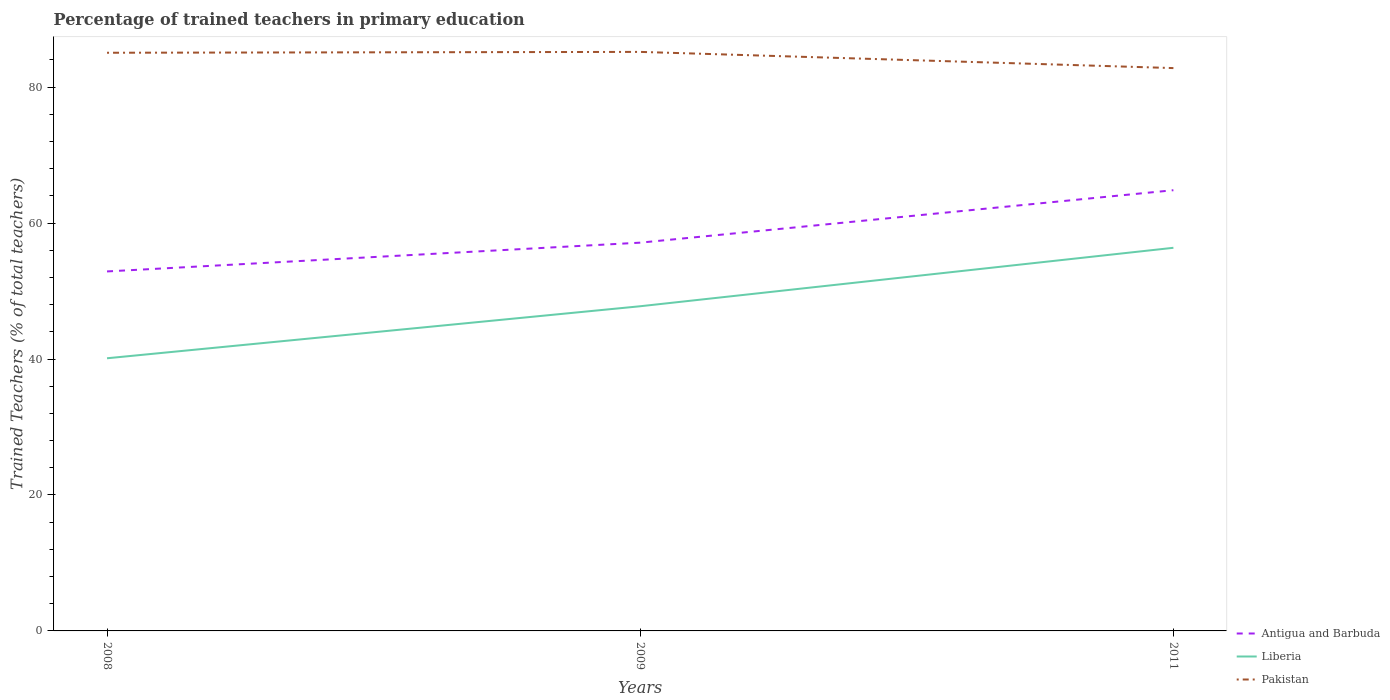How many different coloured lines are there?
Your answer should be very brief. 3. Across all years, what is the maximum percentage of trained teachers in Pakistan?
Your answer should be very brief. 82.81. What is the total percentage of trained teachers in Liberia in the graph?
Give a very brief answer. -7.65. What is the difference between the highest and the second highest percentage of trained teachers in Antigua and Barbuda?
Ensure brevity in your answer.  11.95. What is the difference between two consecutive major ticks on the Y-axis?
Keep it short and to the point. 20. Does the graph contain grids?
Ensure brevity in your answer.  No. Where does the legend appear in the graph?
Provide a succinct answer. Bottom right. How are the legend labels stacked?
Your response must be concise. Vertical. What is the title of the graph?
Provide a short and direct response. Percentage of trained teachers in primary education. What is the label or title of the Y-axis?
Your response must be concise. Trained Teachers (% of total teachers). What is the Trained Teachers (% of total teachers) in Antigua and Barbuda in 2008?
Offer a terse response. 52.89. What is the Trained Teachers (% of total teachers) of Liberia in 2008?
Ensure brevity in your answer.  40.11. What is the Trained Teachers (% of total teachers) of Pakistan in 2008?
Offer a very short reply. 85.06. What is the Trained Teachers (% of total teachers) of Antigua and Barbuda in 2009?
Offer a very short reply. 57.12. What is the Trained Teachers (% of total teachers) in Liberia in 2009?
Keep it short and to the point. 47.77. What is the Trained Teachers (% of total teachers) of Pakistan in 2009?
Provide a short and direct response. 85.19. What is the Trained Teachers (% of total teachers) in Antigua and Barbuda in 2011?
Your answer should be very brief. 64.84. What is the Trained Teachers (% of total teachers) in Liberia in 2011?
Your answer should be compact. 56.37. What is the Trained Teachers (% of total teachers) of Pakistan in 2011?
Make the answer very short. 82.81. Across all years, what is the maximum Trained Teachers (% of total teachers) of Antigua and Barbuda?
Your answer should be compact. 64.84. Across all years, what is the maximum Trained Teachers (% of total teachers) in Liberia?
Make the answer very short. 56.37. Across all years, what is the maximum Trained Teachers (% of total teachers) in Pakistan?
Offer a very short reply. 85.19. Across all years, what is the minimum Trained Teachers (% of total teachers) of Antigua and Barbuda?
Ensure brevity in your answer.  52.89. Across all years, what is the minimum Trained Teachers (% of total teachers) in Liberia?
Provide a short and direct response. 40.11. Across all years, what is the minimum Trained Teachers (% of total teachers) in Pakistan?
Offer a terse response. 82.81. What is the total Trained Teachers (% of total teachers) of Antigua and Barbuda in the graph?
Provide a succinct answer. 174.85. What is the total Trained Teachers (% of total teachers) of Liberia in the graph?
Your answer should be very brief. 144.25. What is the total Trained Teachers (% of total teachers) of Pakistan in the graph?
Your response must be concise. 253.06. What is the difference between the Trained Teachers (% of total teachers) of Antigua and Barbuda in 2008 and that in 2009?
Your response must be concise. -4.23. What is the difference between the Trained Teachers (% of total teachers) of Liberia in 2008 and that in 2009?
Your answer should be compact. -7.65. What is the difference between the Trained Teachers (% of total teachers) in Pakistan in 2008 and that in 2009?
Your answer should be very brief. -0.13. What is the difference between the Trained Teachers (% of total teachers) in Antigua and Barbuda in 2008 and that in 2011?
Your answer should be compact. -11.95. What is the difference between the Trained Teachers (% of total teachers) in Liberia in 2008 and that in 2011?
Keep it short and to the point. -16.25. What is the difference between the Trained Teachers (% of total teachers) in Pakistan in 2008 and that in 2011?
Offer a very short reply. 2.26. What is the difference between the Trained Teachers (% of total teachers) of Antigua and Barbuda in 2009 and that in 2011?
Provide a succinct answer. -7.72. What is the difference between the Trained Teachers (% of total teachers) of Liberia in 2009 and that in 2011?
Keep it short and to the point. -8.6. What is the difference between the Trained Teachers (% of total teachers) in Pakistan in 2009 and that in 2011?
Provide a short and direct response. 2.38. What is the difference between the Trained Teachers (% of total teachers) of Antigua and Barbuda in 2008 and the Trained Teachers (% of total teachers) of Liberia in 2009?
Ensure brevity in your answer.  5.12. What is the difference between the Trained Teachers (% of total teachers) of Antigua and Barbuda in 2008 and the Trained Teachers (% of total teachers) of Pakistan in 2009?
Keep it short and to the point. -32.3. What is the difference between the Trained Teachers (% of total teachers) in Liberia in 2008 and the Trained Teachers (% of total teachers) in Pakistan in 2009?
Offer a very short reply. -45.07. What is the difference between the Trained Teachers (% of total teachers) in Antigua and Barbuda in 2008 and the Trained Teachers (% of total teachers) in Liberia in 2011?
Provide a short and direct response. -3.48. What is the difference between the Trained Teachers (% of total teachers) in Antigua and Barbuda in 2008 and the Trained Teachers (% of total teachers) in Pakistan in 2011?
Keep it short and to the point. -29.92. What is the difference between the Trained Teachers (% of total teachers) of Liberia in 2008 and the Trained Teachers (% of total teachers) of Pakistan in 2011?
Your answer should be very brief. -42.69. What is the difference between the Trained Teachers (% of total teachers) of Antigua and Barbuda in 2009 and the Trained Teachers (% of total teachers) of Liberia in 2011?
Give a very brief answer. 0.76. What is the difference between the Trained Teachers (% of total teachers) in Antigua and Barbuda in 2009 and the Trained Teachers (% of total teachers) in Pakistan in 2011?
Your response must be concise. -25.68. What is the difference between the Trained Teachers (% of total teachers) in Liberia in 2009 and the Trained Teachers (% of total teachers) in Pakistan in 2011?
Provide a short and direct response. -35.04. What is the average Trained Teachers (% of total teachers) in Antigua and Barbuda per year?
Ensure brevity in your answer.  58.28. What is the average Trained Teachers (% of total teachers) of Liberia per year?
Offer a terse response. 48.08. What is the average Trained Teachers (% of total teachers) of Pakistan per year?
Make the answer very short. 84.35. In the year 2008, what is the difference between the Trained Teachers (% of total teachers) of Antigua and Barbuda and Trained Teachers (% of total teachers) of Liberia?
Ensure brevity in your answer.  12.78. In the year 2008, what is the difference between the Trained Teachers (% of total teachers) in Antigua and Barbuda and Trained Teachers (% of total teachers) in Pakistan?
Provide a succinct answer. -32.17. In the year 2008, what is the difference between the Trained Teachers (% of total teachers) of Liberia and Trained Teachers (% of total teachers) of Pakistan?
Your answer should be very brief. -44.95. In the year 2009, what is the difference between the Trained Teachers (% of total teachers) in Antigua and Barbuda and Trained Teachers (% of total teachers) in Liberia?
Give a very brief answer. 9.36. In the year 2009, what is the difference between the Trained Teachers (% of total teachers) of Antigua and Barbuda and Trained Teachers (% of total teachers) of Pakistan?
Make the answer very short. -28.07. In the year 2009, what is the difference between the Trained Teachers (% of total teachers) in Liberia and Trained Teachers (% of total teachers) in Pakistan?
Provide a short and direct response. -37.42. In the year 2011, what is the difference between the Trained Teachers (% of total teachers) of Antigua and Barbuda and Trained Teachers (% of total teachers) of Liberia?
Offer a very short reply. 8.47. In the year 2011, what is the difference between the Trained Teachers (% of total teachers) of Antigua and Barbuda and Trained Teachers (% of total teachers) of Pakistan?
Your answer should be compact. -17.97. In the year 2011, what is the difference between the Trained Teachers (% of total teachers) in Liberia and Trained Teachers (% of total teachers) in Pakistan?
Offer a very short reply. -26.44. What is the ratio of the Trained Teachers (% of total teachers) of Antigua and Barbuda in 2008 to that in 2009?
Offer a very short reply. 0.93. What is the ratio of the Trained Teachers (% of total teachers) of Liberia in 2008 to that in 2009?
Make the answer very short. 0.84. What is the ratio of the Trained Teachers (% of total teachers) of Antigua and Barbuda in 2008 to that in 2011?
Your response must be concise. 0.82. What is the ratio of the Trained Teachers (% of total teachers) of Liberia in 2008 to that in 2011?
Provide a short and direct response. 0.71. What is the ratio of the Trained Teachers (% of total teachers) in Pakistan in 2008 to that in 2011?
Offer a terse response. 1.03. What is the ratio of the Trained Teachers (% of total teachers) of Antigua and Barbuda in 2009 to that in 2011?
Your answer should be compact. 0.88. What is the ratio of the Trained Teachers (% of total teachers) in Liberia in 2009 to that in 2011?
Ensure brevity in your answer.  0.85. What is the ratio of the Trained Teachers (% of total teachers) in Pakistan in 2009 to that in 2011?
Offer a terse response. 1.03. What is the difference between the highest and the second highest Trained Teachers (% of total teachers) of Antigua and Barbuda?
Give a very brief answer. 7.72. What is the difference between the highest and the second highest Trained Teachers (% of total teachers) in Liberia?
Ensure brevity in your answer.  8.6. What is the difference between the highest and the second highest Trained Teachers (% of total teachers) in Pakistan?
Your answer should be very brief. 0.13. What is the difference between the highest and the lowest Trained Teachers (% of total teachers) of Antigua and Barbuda?
Give a very brief answer. 11.95. What is the difference between the highest and the lowest Trained Teachers (% of total teachers) of Liberia?
Offer a terse response. 16.25. What is the difference between the highest and the lowest Trained Teachers (% of total teachers) of Pakistan?
Offer a very short reply. 2.38. 